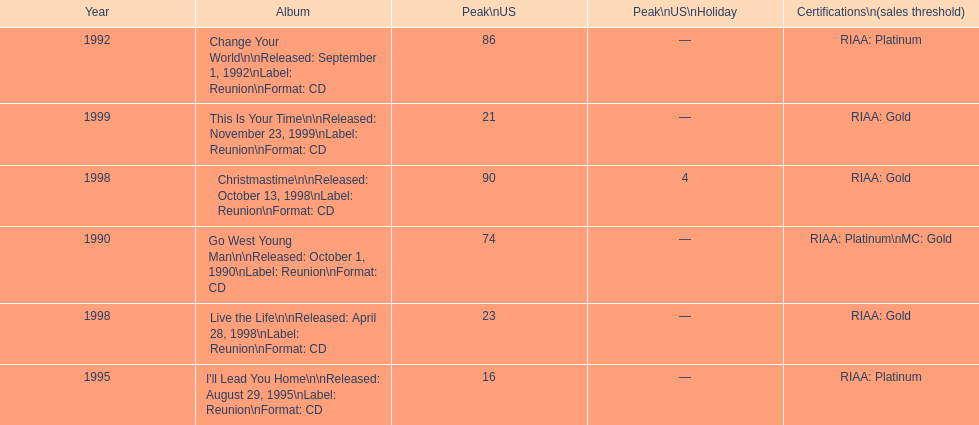The oldest year listed is what? 1990. 